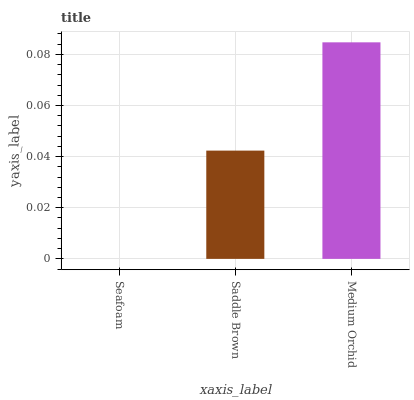Is Seafoam the minimum?
Answer yes or no. Yes. Is Medium Orchid the maximum?
Answer yes or no. Yes. Is Saddle Brown the minimum?
Answer yes or no. No. Is Saddle Brown the maximum?
Answer yes or no. No. Is Saddle Brown greater than Seafoam?
Answer yes or no. Yes. Is Seafoam less than Saddle Brown?
Answer yes or no. Yes. Is Seafoam greater than Saddle Brown?
Answer yes or no. No. Is Saddle Brown less than Seafoam?
Answer yes or no. No. Is Saddle Brown the high median?
Answer yes or no. Yes. Is Saddle Brown the low median?
Answer yes or no. Yes. Is Seafoam the high median?
Answer yes or no. No. Is Seafoam the low median?
Answer yes or no. No. 